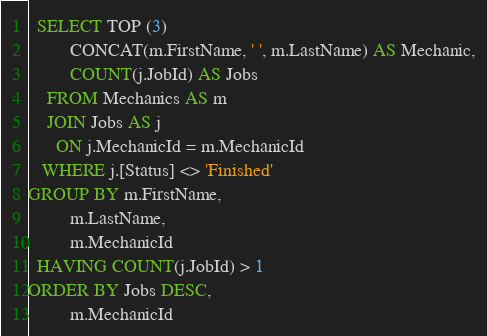Convert code to text. <code><loc_0><loc_0><loc_500><loc_500><_SQL_>  SELECT TOP (3) 
		 CONCAT(m.FirstName, ' ', m.LastName) AS Mechanic,
  	     COUNT(j.JobId) AS Jobs
    FROM Mechanics AS m
    JOIN Jobs AS j
      ON j.MechanicId = m.MechanicId
   WHERE j.[Status] <> 'Finished'
GROUP BY m.FirstName,
		 m.LastName,
		 m.MechanicId
  HAVING COUNT(j.JobId) > 1
ORDER BY Jobs DESC,
		 m.MechanicId</code> 